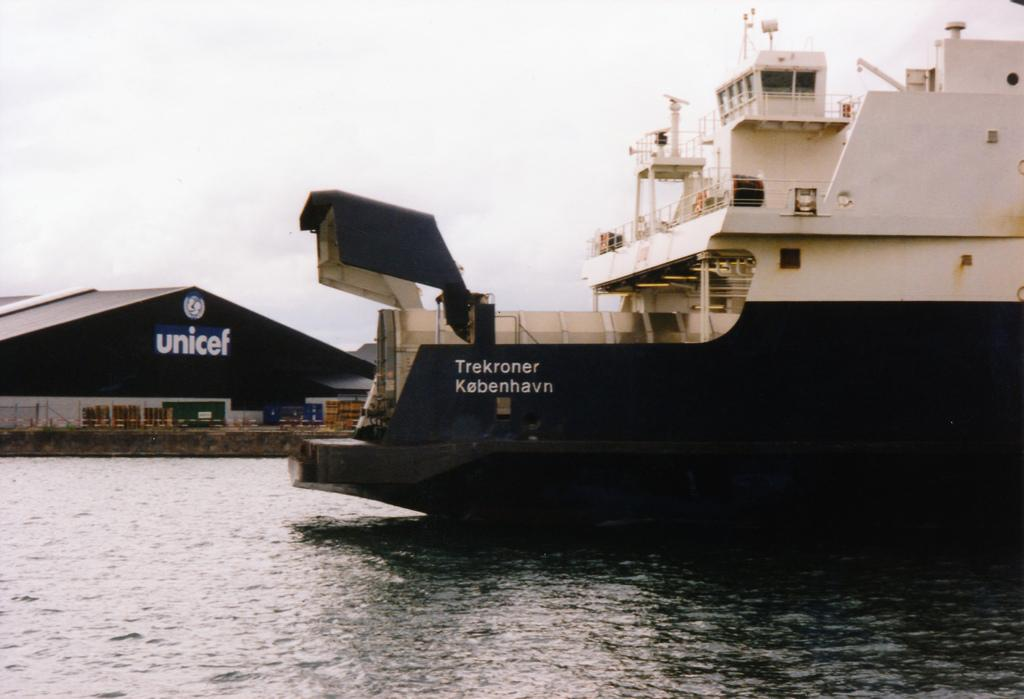<image>
Share a concise interpretation of the image provided. Ship on the water near the shore with a unicef building in the background. 